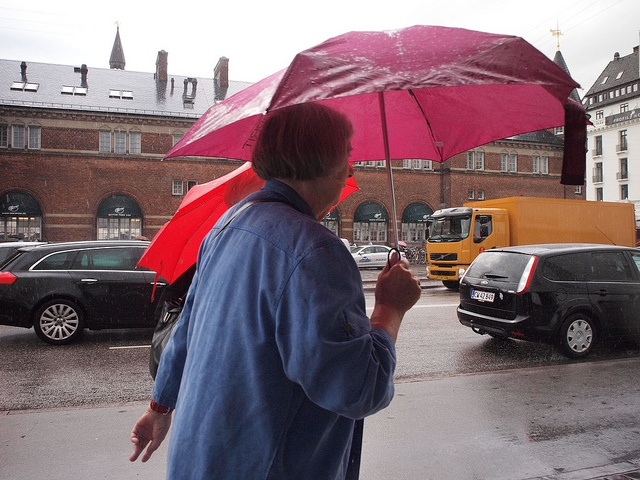Describe the objects in this image and their specific colors. I can see people in white, black, navy, gray, and maroon tones, umbrella in white, brown, and maroon tones, car in white, black, gray, darkgray, and lightgray tones, car in white, black, gray, darkgray, and lightgray tones, and truck in white, red, salmon, black, and gray tones in this image. 